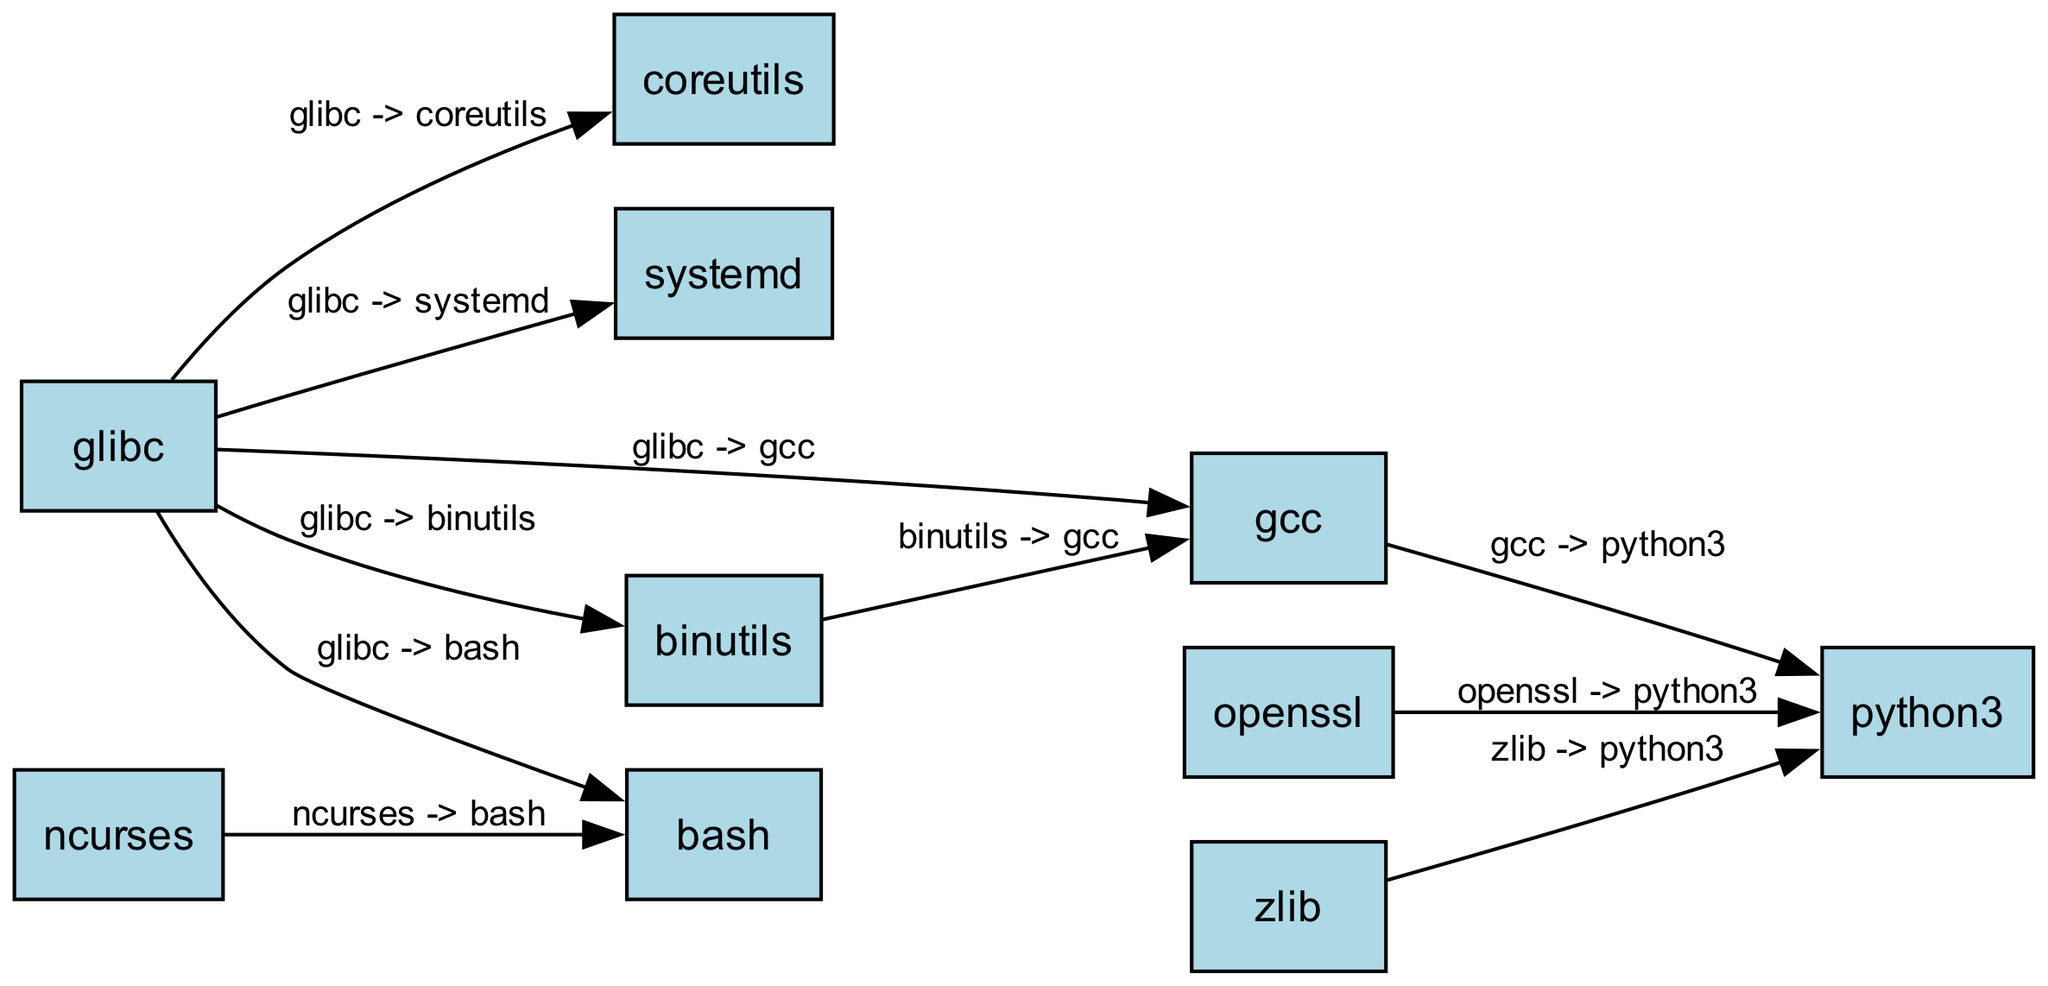What is the total number of nodes in the diagram? By counting the unique software package nodes listed in the data, we find there are 10 distinct nodes: glibc, gcc, binutils, bash, coreutils, systemd, python3, openssl, zlib, ncurses.
Answer: 10 Which package does glibc directly depend on? Looking at the edges that originate from glibc, we identify gcc, binutils, bash, coreutils, and systemd as its direct dependencies.
Answer: gcc, binutils, bash, coreutils, systemd How many packages depend on python3? Reading through the edges, we see that both gcc, openssl, and zlib have edges directed towards python3, indicating that three packages depend on it.
Answer: 3 Which two packages have a circular dependency? When analyzing the edges, we find that both gcc and binutils depend on each other, confirming a circular dependency exists between them.
Answer: gcc, binutils What is the total number of edges in the diagram? Counting all relationships (edges) between nodes, we observe 10 directed edges connecting the packages.
Answer: 10 Which package is a dependency for both bash and python3? Reviewing the edges, we identify that both bash and python3 have dependencies leading back towards glibc (directly for bash and indirectly through gcc for python3).
Answer: glibc From the diagram, which package depends on the most other packages? By evaluating the node connections, glibc has edges leading to five other packages (gcc, binutils, bash, coreutils, and systemd), thus establishing it as the most dependent package in the graph.
Answer: glibc What is the direct dependency of ncurses? Looking at the edges, we see that ncurses has only one outgoing edge that leads to bash, indicating it has no other direct dependencies.
Answer: bash 